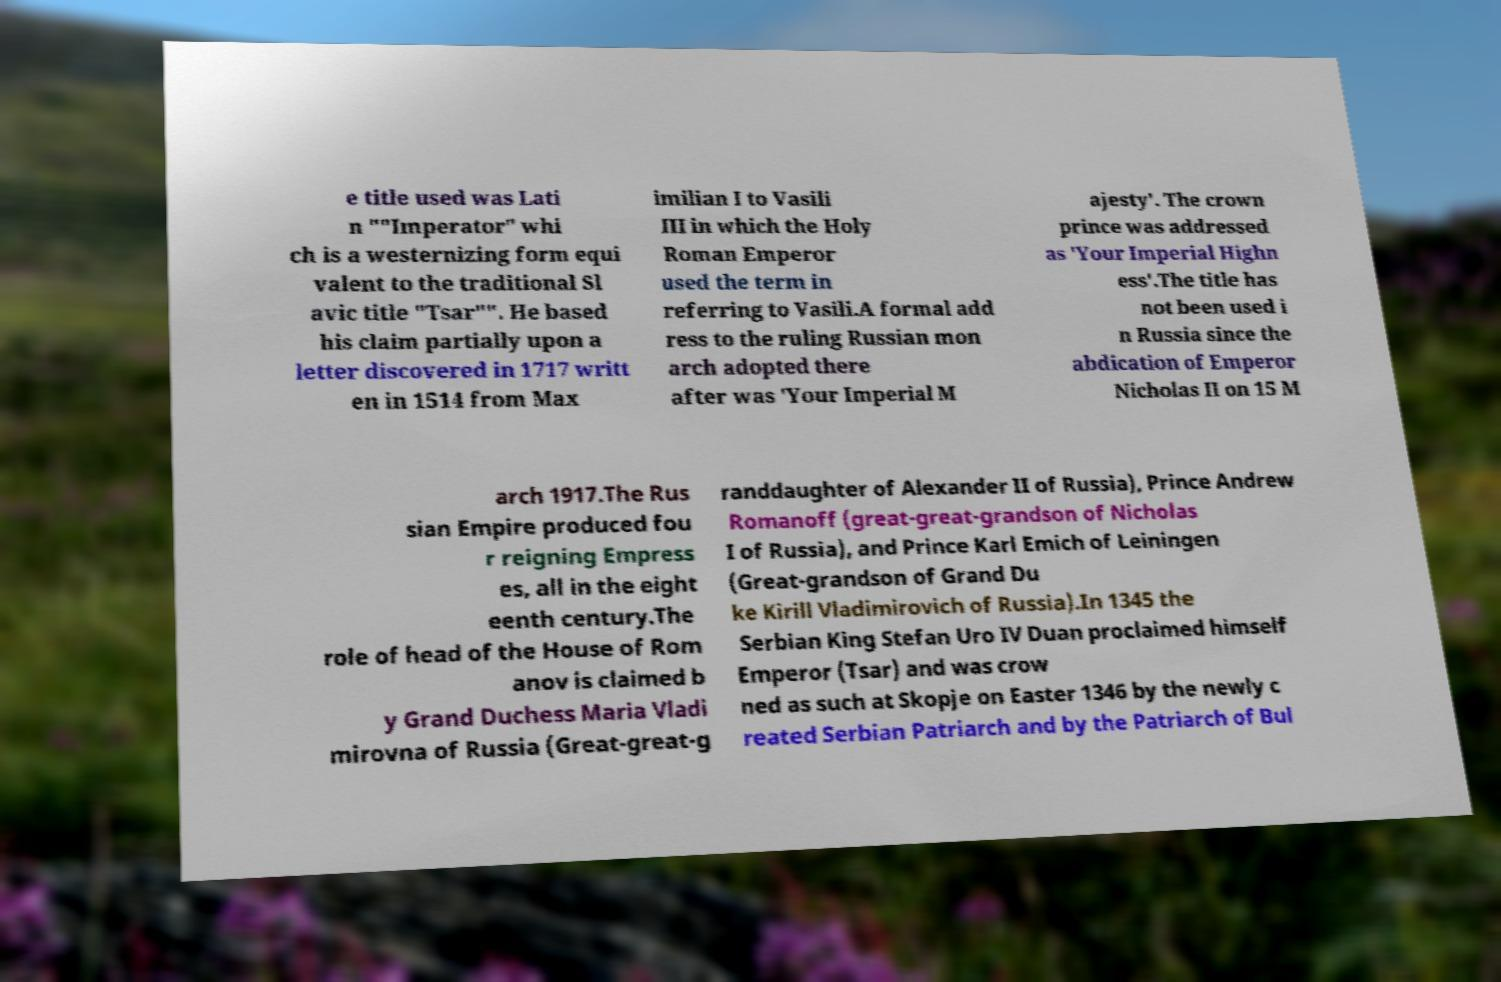Please identify and transcribe the text found in this image. e title used was Lati n ""Imperator" whi ch is a westernizing form equi valent to the traditional Sl avic title "Tsar"". He based his claim partially upon a letter discovered in 1717 writt en in 1514 from Max imilian I to Vasili III in which the Holy Roman Emperor used the term in referring to Vasili.A formal add ress to the ruling Russian mon arch adopted there after was 'Your Imperial M ajesty'. The crown prince was addressed as 'Your Imperial Highn ess'.The title has not been used i n Russia since the abdication of Emperor Nicholas II on 15 M arch 1917.The Rus sian Empire produced fou r reigning Empress es, all in the eight eenth century.The role of head of the House of Rom anov is claimed b y Grand Duchess Maria Vladi mirovna of Russia (Great-great-g randdaughter of Alexander II of Russia), Prince Andrew Romanoff (great-great-grandson of Nicholas I of Russia), and Prince Karl Emich of Leiningen (Great-grandson of Grand Du ke Kirill Vladimirovich of Russia).In 1345 the Serbian King Stefan Uro IV Duan proclaimed himself Emperor (Tsar) and was crow ned as such at Skopje on Easter 1346 by the newly c reated Serbian Patriarch and by the Patriarch of Bul 